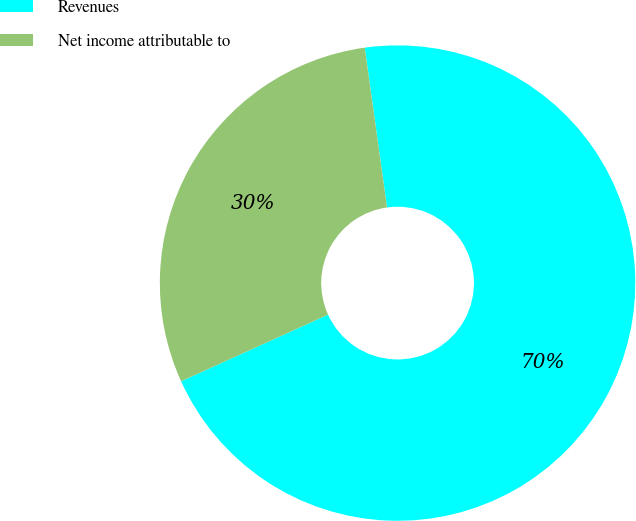Convert chart to OTSL. <chart><loc_0><loc_0><loc_500><loc_500><pie_chart><fcel>Revenues<fcel>Net income attributable to<nl><fcel>70.43%<fcel>29.57%<nl></chart> 